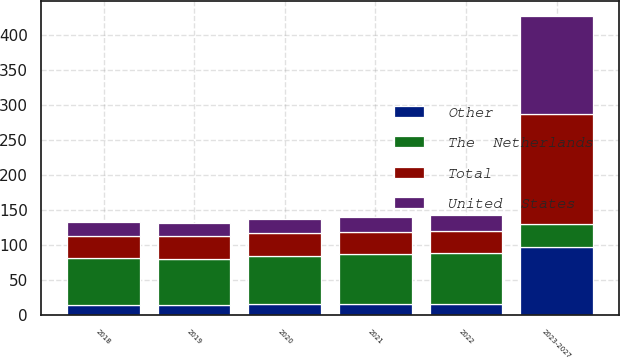Convert chart to OTSL. <chart><loc_0><loc_0><loc_500><loc_500><stacked_bar_chart><ecel><fcel>2018<fcel>2019<fcel>2020<fcel>2021<fcel>2022<fcel>2023-2027<nl><fcel>Total<fcel>32<fcel>32<fcel>32<fcel>32<fcel>32<fcel>158<nl><fcel>Other<fcel>15<fcel>15<fcel>16<fcel>17<fcel>17<fcel>98<nl><fcel>United  States<fcel>20<fcel>19<fcel>21<fcel>21<fcel>23<fcel>139<nl><fcel>The  Netherlands<fcel>67<fcel>66<fcel>69<fcel>70<fcel>72<fcel>32<nl></chart> 